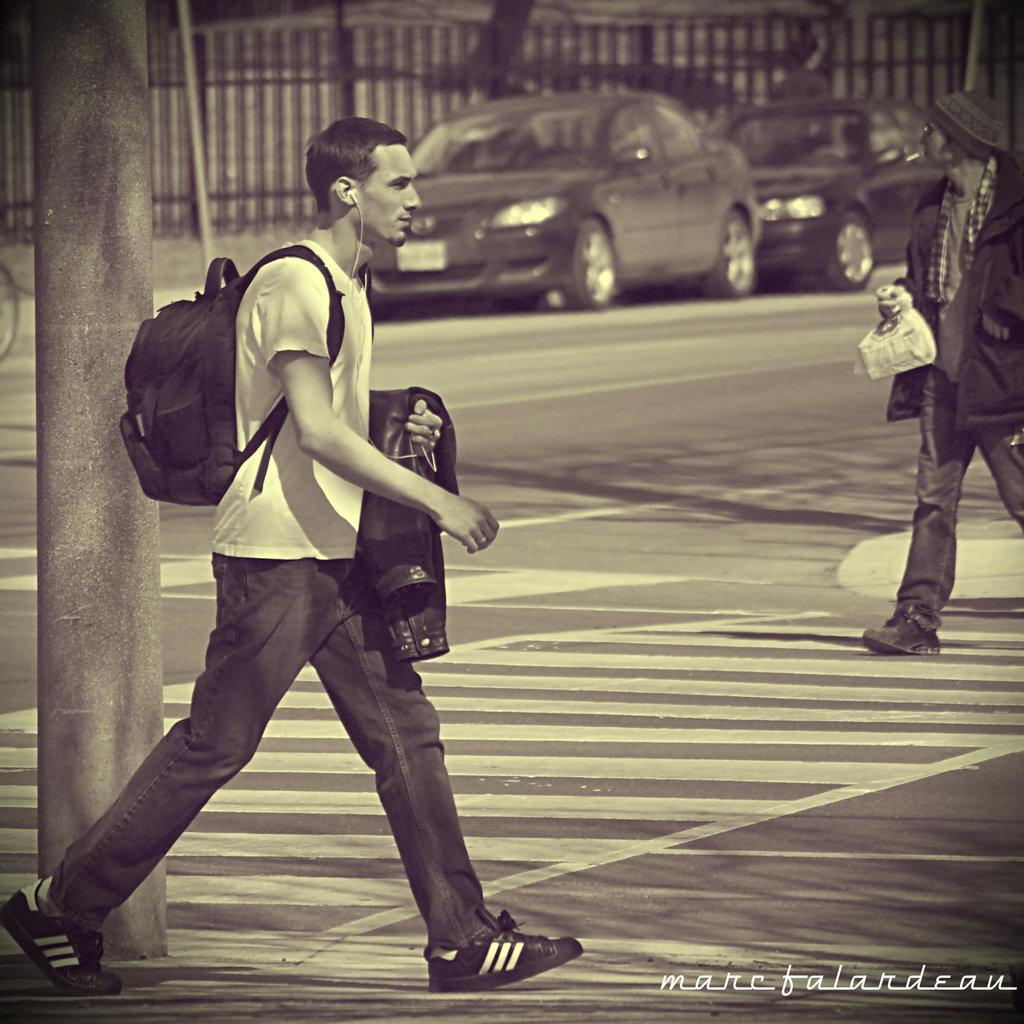What are the two people in the image doing? The two people in the image are walking on the road. What else can be seen in the image besides the people? There are two parked cars and a pole visible in the image. Is there any text or marking on the image? Yes, there is a watermark at the bottom of the image. What type of toothpaste is the brother using in the image? There is no toothpaste or brother present in the image. What is on the plate that the people are carrying in the image? There is no plate or indication of carrying anything in the image. 